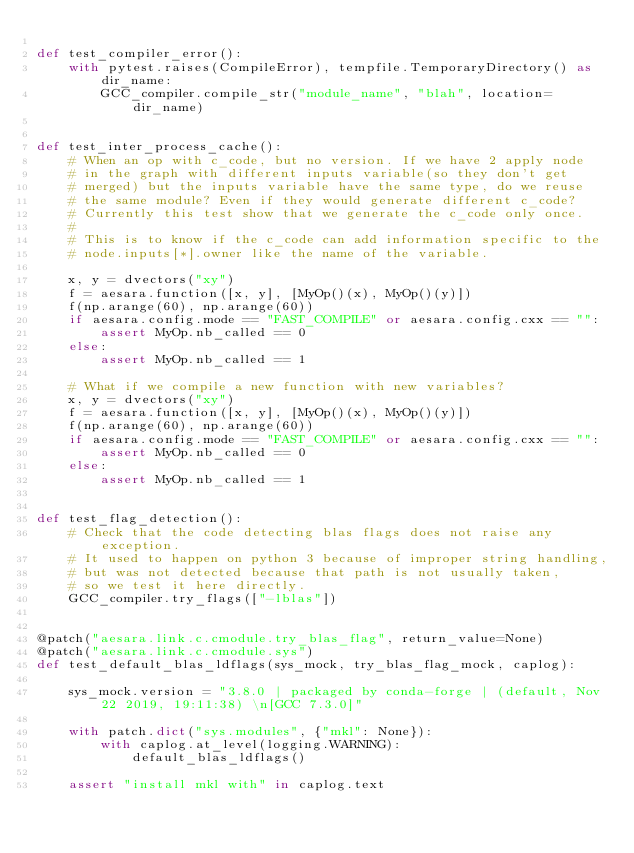Convert code to text. <code><loc_0><loc_0><loc_500><loc_500><_Python_>
def test_compiler_error():
    with pytest.raises(CompileError), tempfile.TemporaryDirectory() as dir_name:
        GCC_compiler.compile_str("module_name", "blah", location=dir_name)


def test_inter_process_cache():
    # When an op with c_code, but no version. If we have 2 apply node
    # in the graph with different inputs variable(so they don't get
    # merged) but the inputs variable have the same type, do we reuse
    # the same module? Even if they would generate different c_code?
    # Currently this test show that we generate the c_code only once.
    #
    # This is to know if the c_code can add information specific to the
    # node.inputs[*].owner like the name of the variable.

    x, y = dvectors("xy")
    f = aesara.function([x, y], [MyOp()(x), MyOp()(y)])
    f(np.arange(60), np.arange(60))
    if aesara.config.mode == "FAST_COMPILE" or aesara.config.cxx == "":
        assert MyOp.nb_called == 0
    else:
        assert MyOp.nb_called == 1

    # What if we compile a new function with new variables?
    x, y = dvectors("xy")
    f = aesara.function([x, y], [MyOp()(x), MyOp()(y)])
    f(np.arange(60), np.arange(60))
    if aesara.config.mode == "FAST_COMPILE" or aesara.config.cxx == "":
        assert MyOp.nb_called == 0
    else:
        assert MyOp.nb_called == 1


def test_flag_detection():
    # Check that the code detecting blas flags does not raise any exception.
    # It used to happen on python 3 because of improper string handling,
    # but was not detected because that path is not usually taken,
    # so we test it here directly.
    GCC_compiler.try_flags(["-lblas"])


@patch("aesara.link.c.cmodule.try_blas_flag", return_value=None)
@patch("aesara.link.c.cmodule.sys")
def test_default_blas_ldflags(sys_mock, try_blas_flag_mock, caplog):

    sys_mock.version = "3.8.0 | packaged by conda-forge | (default, Nov 22 2019, 19:11:38) \n[GCC 7.3.0]"

    with patch.dict("sys.modules", {"mkl": None}):
        with caplog.at_level(logging.WARNING):
            default_blas_ldflags()

    assert "install mkl with" in caplog.text
</code> 